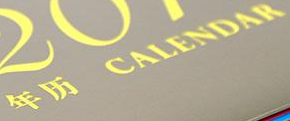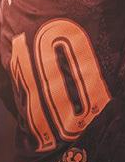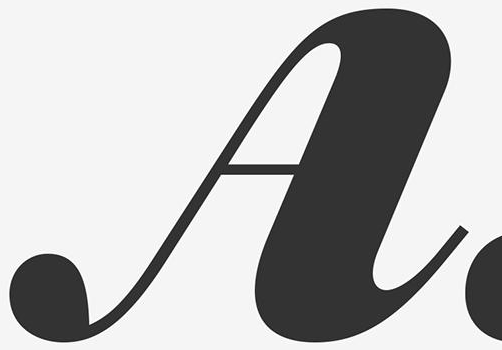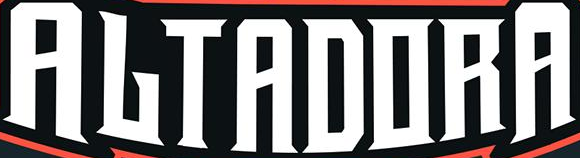What words can you see in these images in sequence, separated by a semicolon? #; 10; A; ALTADORA 